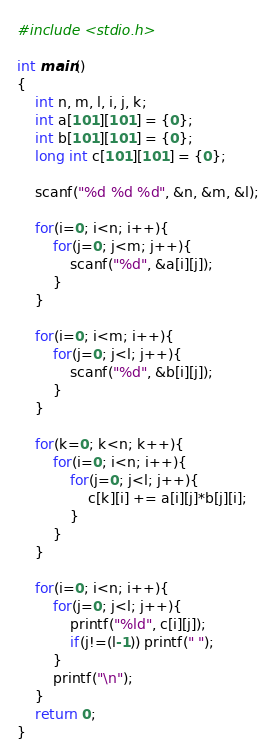Convert code to text. <code><loc_0><loc_0><loc_500><loc_500><_C_>#include <stdio.h>

int main()
{
    int n, m, l, i, j, k;
    int a[101][101] = {0};
    int b[101][101] = {0};
    long int c[101][101] = {0};
    
    scanf("%d %d %d", &n, &m, &l);
    
    for(i=0; i<n; i++){
        for(j=0; j<m; j++){
            scanf("%d", &a[i][j]);
        }
    }
    
    for(i=0; i<m; i++){
        for(j=0; j<l; j++){
            scanf("%d", &b[i][j]);
        }
    }
    
    for(k=0; k<n; k++){
        for(i=0; i<n; i++){
            for(j=0; j<l; j++){
                c[k][i] += a[i][j]*b[j][i];
            }
        }
    }
    
    for(i=0; i<n; i++){
        for(j=0; j<l; j++){
            printf("%ld", c[i][j]);
            if(j!=(l-1)) printf(" ");
        }
        printf("\n");
    }
    return 0;
}</code> 